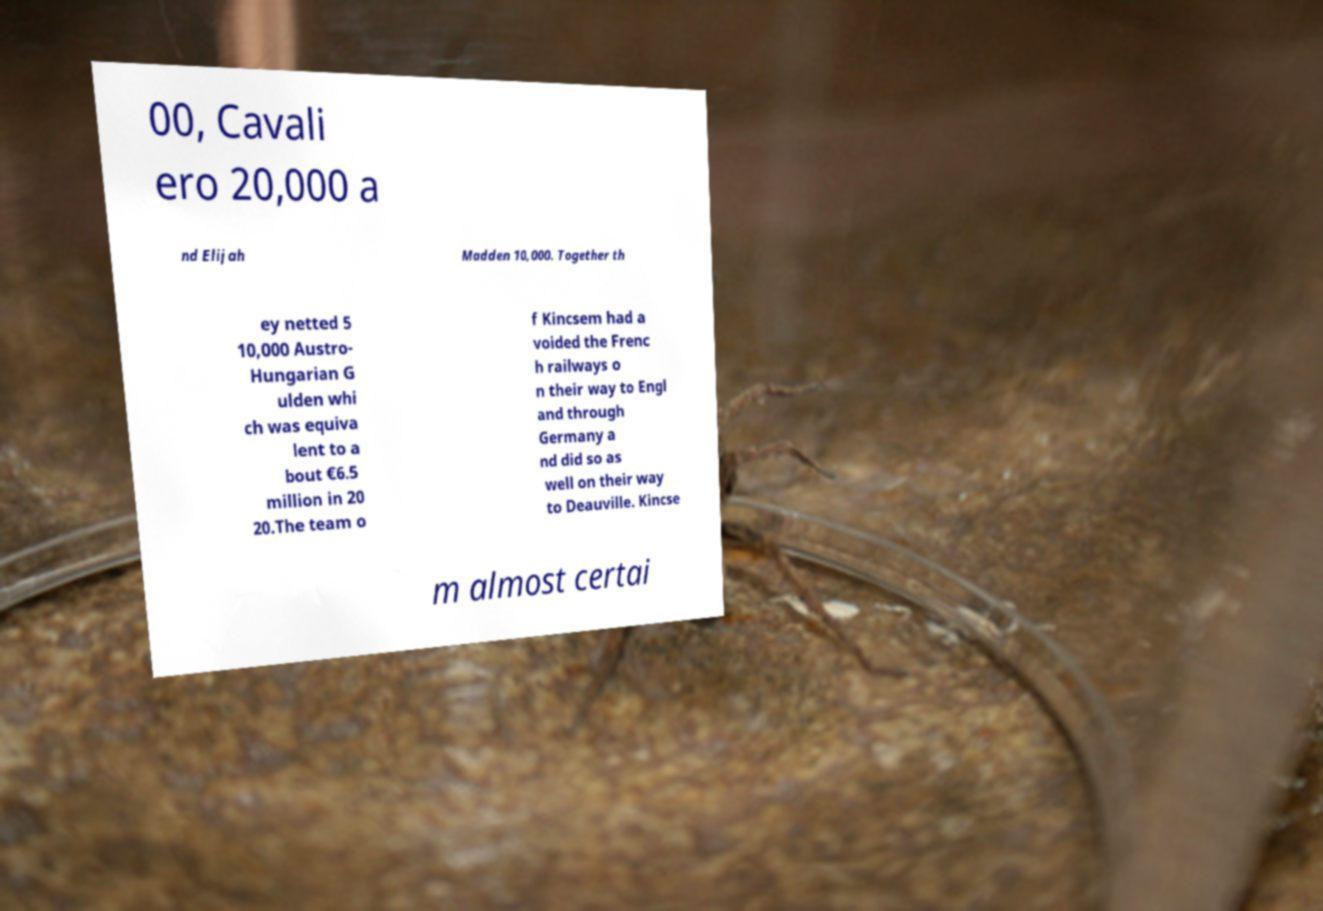Could you assist in decoding the text presented in this image and type it out clearly? 00, Cavali ero 20,000 a nd Elijah Madden 10,000. Together th ey netted 5 10,000 Austro- Hungarian G ulden whi ch was equiva lent to a bout €6.5 million in 20 20.The team o f Kincsem had a voided the Frenc h railways o n their way to Engl and through Germany a nd did so as well on their way to Deauville. Kincse m almost certai 